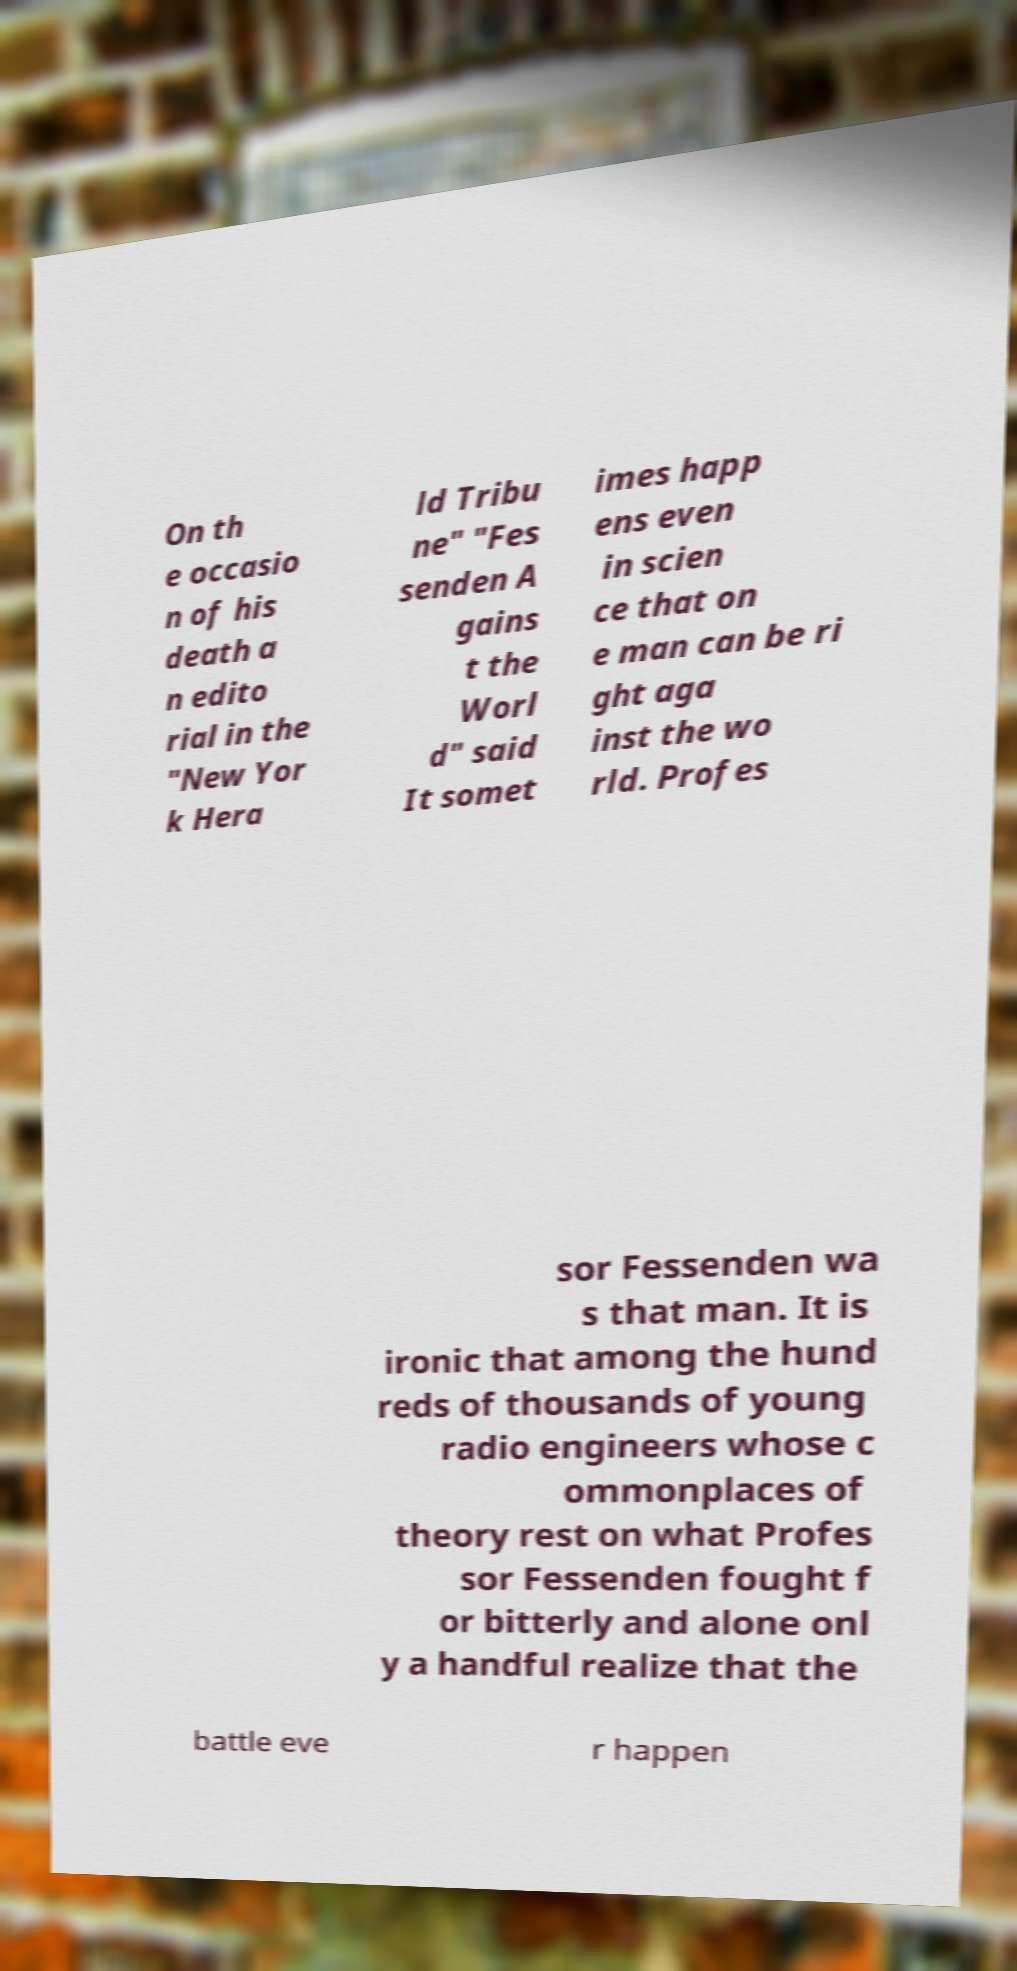Can you read and provide the text displayed in the image?This photo seems to have some interesting text. Can you extract and type it out for me? On th e occasio n of his death a n edito rial in the "New Yor k Hera ld Tribu ne" "Fes senden A gains t the Worl d" said It somet imes happ ens even in scien ce that on e man can be ri ght aga inst the wo rld. Profes sor Fessenden wa s that man. It is ironic that among the hund reds of thousands of young radio engineers whose c ommonplaces of theory rest on what Profes sor Fessenden fought f or bitterly and alone onl y a handful realize that the battle eve r happen 